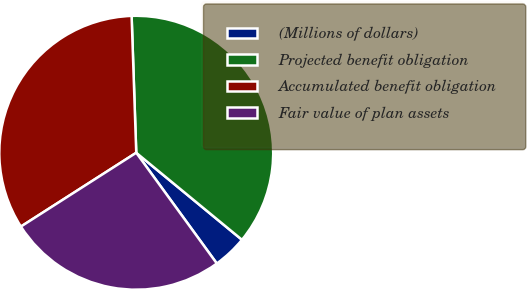Convert chart to OTSL. <chart><loc_0><loc_0><loc_500><loc_500><pie_chart><fcel>(Millions of dollars)<fcel>Projected benefit obligation<fcel>Accumulated benefit obligation<fcel>Fair value of plan assets<nl><fcel>4.03%<fcel>36.5%<fcel>33.52%<fcel>25.95%<nl></chart> 